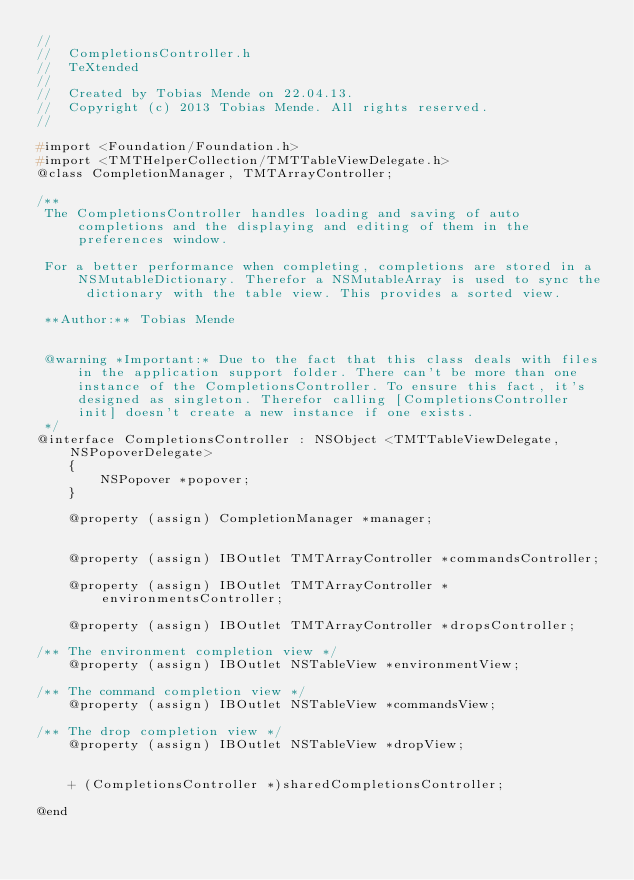<code> <loc_0><loc_0><loc_500><loc_500><_C_>//
//  CompletionsController.h
//  TeXtended
//
//  Created by Tobias Mende on 22.04.13.
//  Copyright (c) 2013 Tobias Mende. All rights reserved.
//

#import <Foundation/Foundation.h>
#import <TMTHelperCollection/TMTTableViewDelegate.h>
@class CompletionManager, TMTArrayController;

/**
 The CompletionsController handles loading and saving of auto completions and the displaying and editing of them in the preferences window.

 For a better performance when completing, completions are stored in a NSMutableDictionary. Therefor a NSMutableArray is used to sync the dictionary with the table view. This provides a sorted view.
 
 **Author:** Tobias Mende
 
 
 @warning *Important:* Due to the fact that this class deals with files in the application support folder. There can't be more than one instance of the CompletionsController. To ensure this fact, it's designed as singleton. Therefor calling [CompletionsController init] doesn't create a new instance if one exists.
 */
@interface CompletionsController : NSObject <TMTTableViewDelegate,NSPopoverDelegate>
    {
        NSPopover *popover;
    }

    @property (assign) CompletionManager *manager;


    @property (assign) IBOutlet TMTArrayController *commandsController;

    @property (assign) IBOutlet TMTArrayController *environmentsController;

    @property (assign) IBOutlet TMTArrayController *dropsController;

/** The environment completion view */
    @property (assign) IBOutlet NSTableView *environmentView;

/** The command completion view */
    @property (assign) IBOutlet NSTableView *commandsView;

/** The drop completion view */
    @property (assign) IBOutlet NSTableView *dropView;


    + (CompletionsController *)sharedCompletionsController;

@end
</code> 